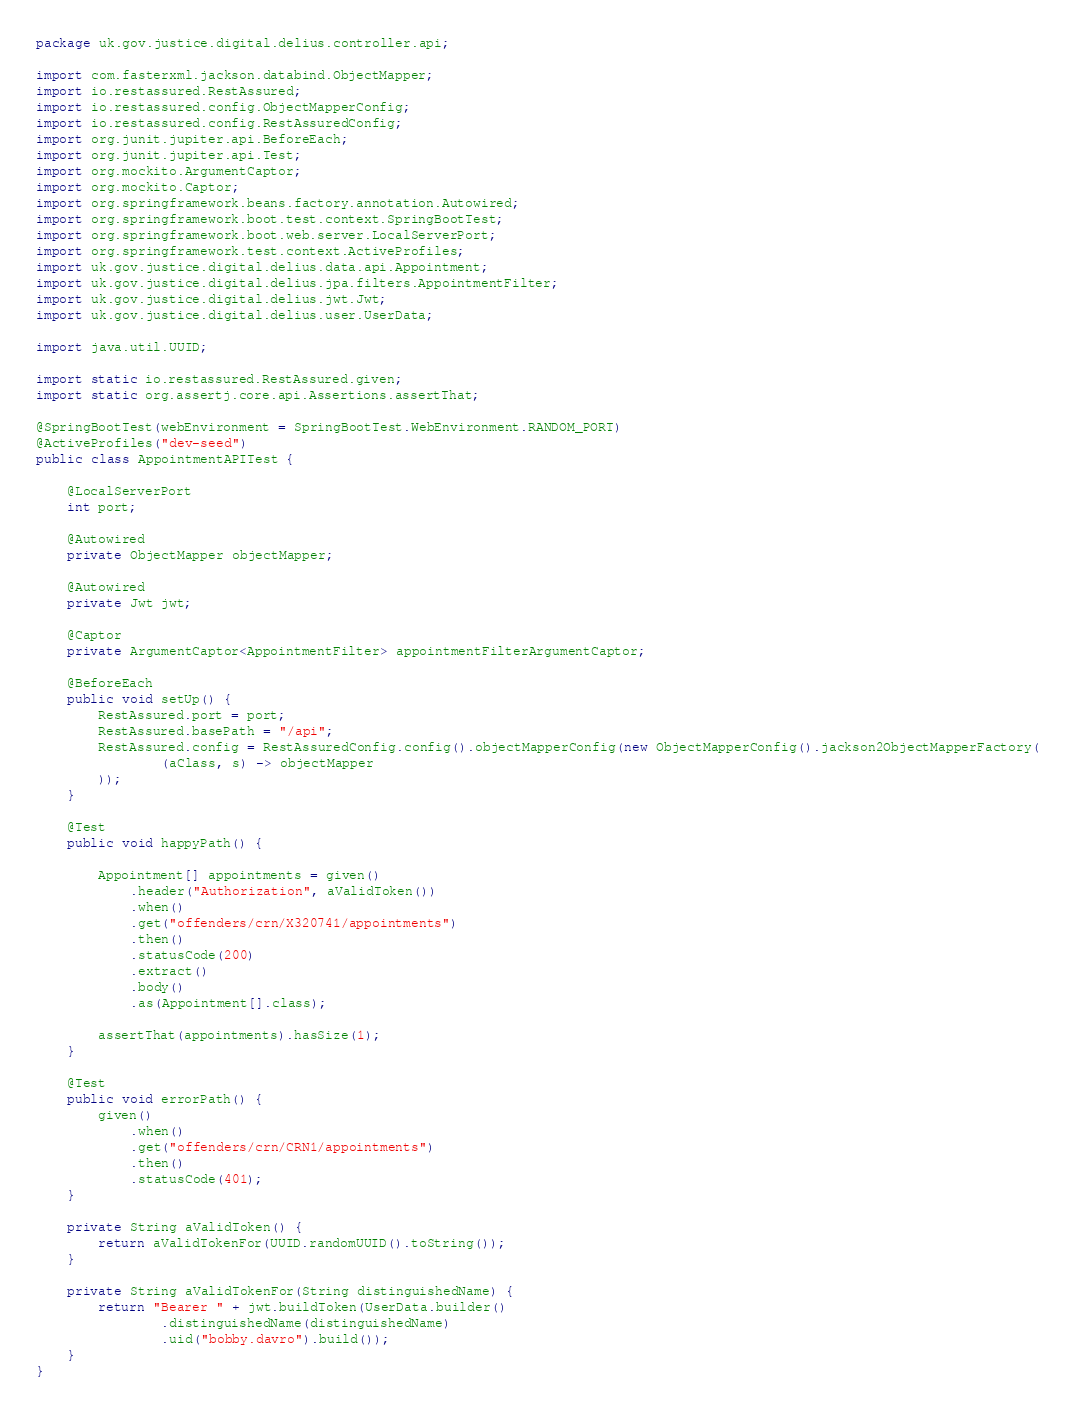Convert code to text. <code><loc_0><loc_0><loc_500><loc_500><_Java_>package uk.gov.justice.digital.delius.controller.api;

import com.fasterxml.jackson.databind.ObjectMapper;
import io.restassured.RestAssured;
import io.restassured.config.ObjectMapperConfig;
import io.restassured.config.RestAssuredConfig;
import org.junit.jupiter.api.BeforeEach;
import org.junit.jupiter.api.Test;
import org.mockito.ArgumentCaptor;
import org.mockito.Captor;
import org.springframework.beans.factory.annotation.Autowired;
import org.springframework.boot.test.context.SpringBootTest;
import org.springframework.boot.web.server.LocalServerPort;
import org.springframework.test.context.ActiveProfiles;
import uk.gov.justice.digital.delius.data.api.Appointment;
import uk.gov.justice.digital.delius.jpa.filters.AppointmentFilter;
import uk.gov.justice.digital.delius.jwt.Jwt;
import uk.gov.justice.digital.delius.user.UserData;

import java.util.UUID;

import static io.restassured.RestAssured.given;
import static org.assertj.core.api.Assertions.assertThat;

@SpringBootTest(webEnvironment = SpringBootTest.WebEnvironment.RANDOM_PORT)
@ActiveProfiles("dev-seed")
public class AppointmentAPITest {

    @LocalServerPort
    int port;

    @Autowired
    private ObjectMapper objectMapper;

    @Autowired
    private Jwt jwt;

    @Captor
    private ArgumentCaptor<AppointmentFilter> appointmentFilterArgumentCaptor;

    @BeforeEach
    public void setUp() {
        RestAssured.port = port;
        RestAssured.basePath = "/api";
        RestAssured.config = RestAssuredConfig.config().objectMapperConfig(new ObjectMapperConfig().jackson2ObjectMapperFactory(
                (aClass, s) -> objectMapper
        ));
    }

    @Test
    public void happyPath() {

        Appointment[] appointments = given()
            .header("Authorization", aValidToken())
            .when()
            .get("offenders/crn/X320741/appointments")
            .then()
            .statusCode(200)
            .extract()
            .body()
            .as(Appointment[].class);

        assertThat(appointments).hasSize(1);
    }

    @Test
    public void errorPath() {
        given()
            .when()
            .get("offenders/crn/CRN1/appointments")
            .then()
            .statusCode(401);
    }

    private String aValidToken() {
        return aValidTokenFor(UUID.randomUUID().toString());
    }

    private String aValidTokenFor(String distinguishedName) {
        return "Bearer " + jwt.buildToken(UserData.builder()
                .distinguishedName(distinguishedName)
                .uid("bobby.davro").build());
    }
}
</code> 